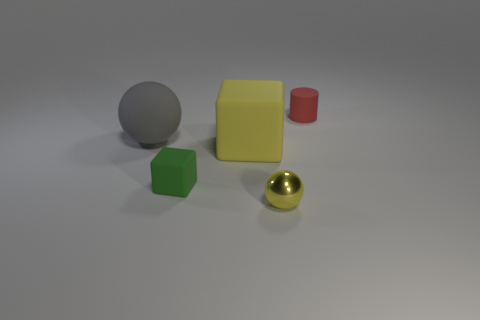Are there any other things that have the same material as the yellow sphere?
Give a very brief answer. No. Is the number of gray rubber things less than the number of tiny yellow matte spheres?
Offer a terse response. No. Is the number of large yellow cubes greater than the number of yellow rubber spheres?
Your response must be concise. Yes. What number of other objects are the same material as the large sphere?
Ensure brevity in your answer.  3. How many tiny yellow things are on the right side of the object that is on the left side of the tiny matte thing to the left of the red rubber object?
Your answer should be compact. 1. What number of rubber things are balls or small cylinders?
Your response must be concise. 2. What size is the sphere that is to the left of the yellow object left of the tiny yellow ball?
Ensure brevity in your answer.  Large. There is a sphere in front of the big yellow matte cube; is its color the same as the cube that is right of the tiny green matte thing?
Offer a terse response. Yes. There is a object that is on the right side of the yellow cube and left of the small cylinder; what color is it?
Your response must be concise. Yellow. Is the material of the large ball the same as the green cube?
Provide a succinct answer. Yes. 